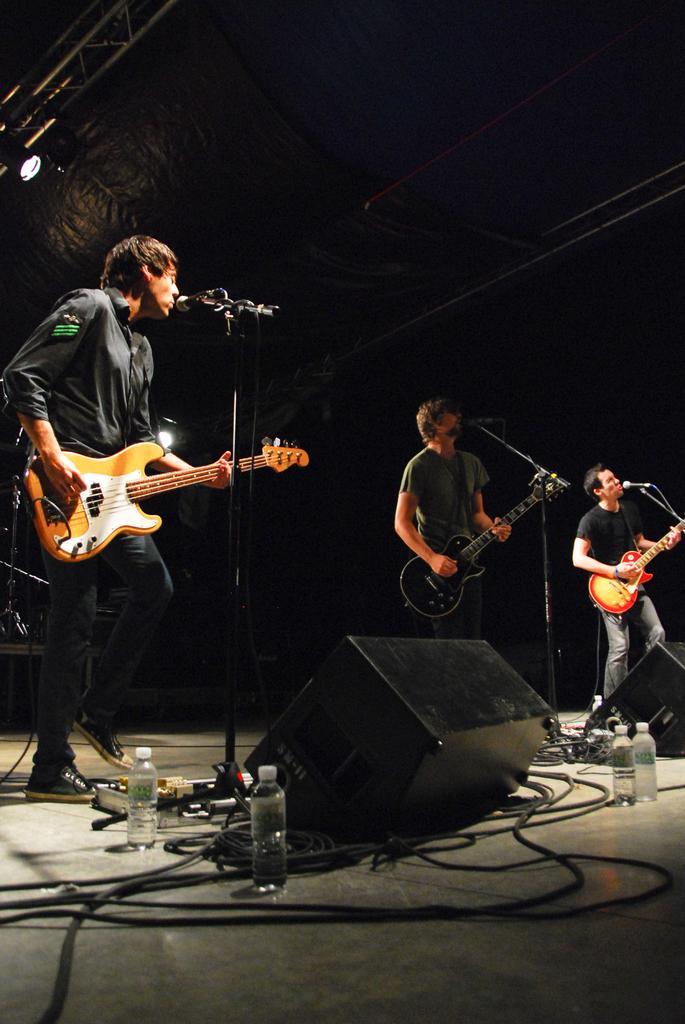Can you describe this image briefly? In this image three persons are standing on the stage. They are playing guitars. Before them there are few mike stands. Few bottles and a device are on the stage. Top of image there are few rods having light attached to it. 